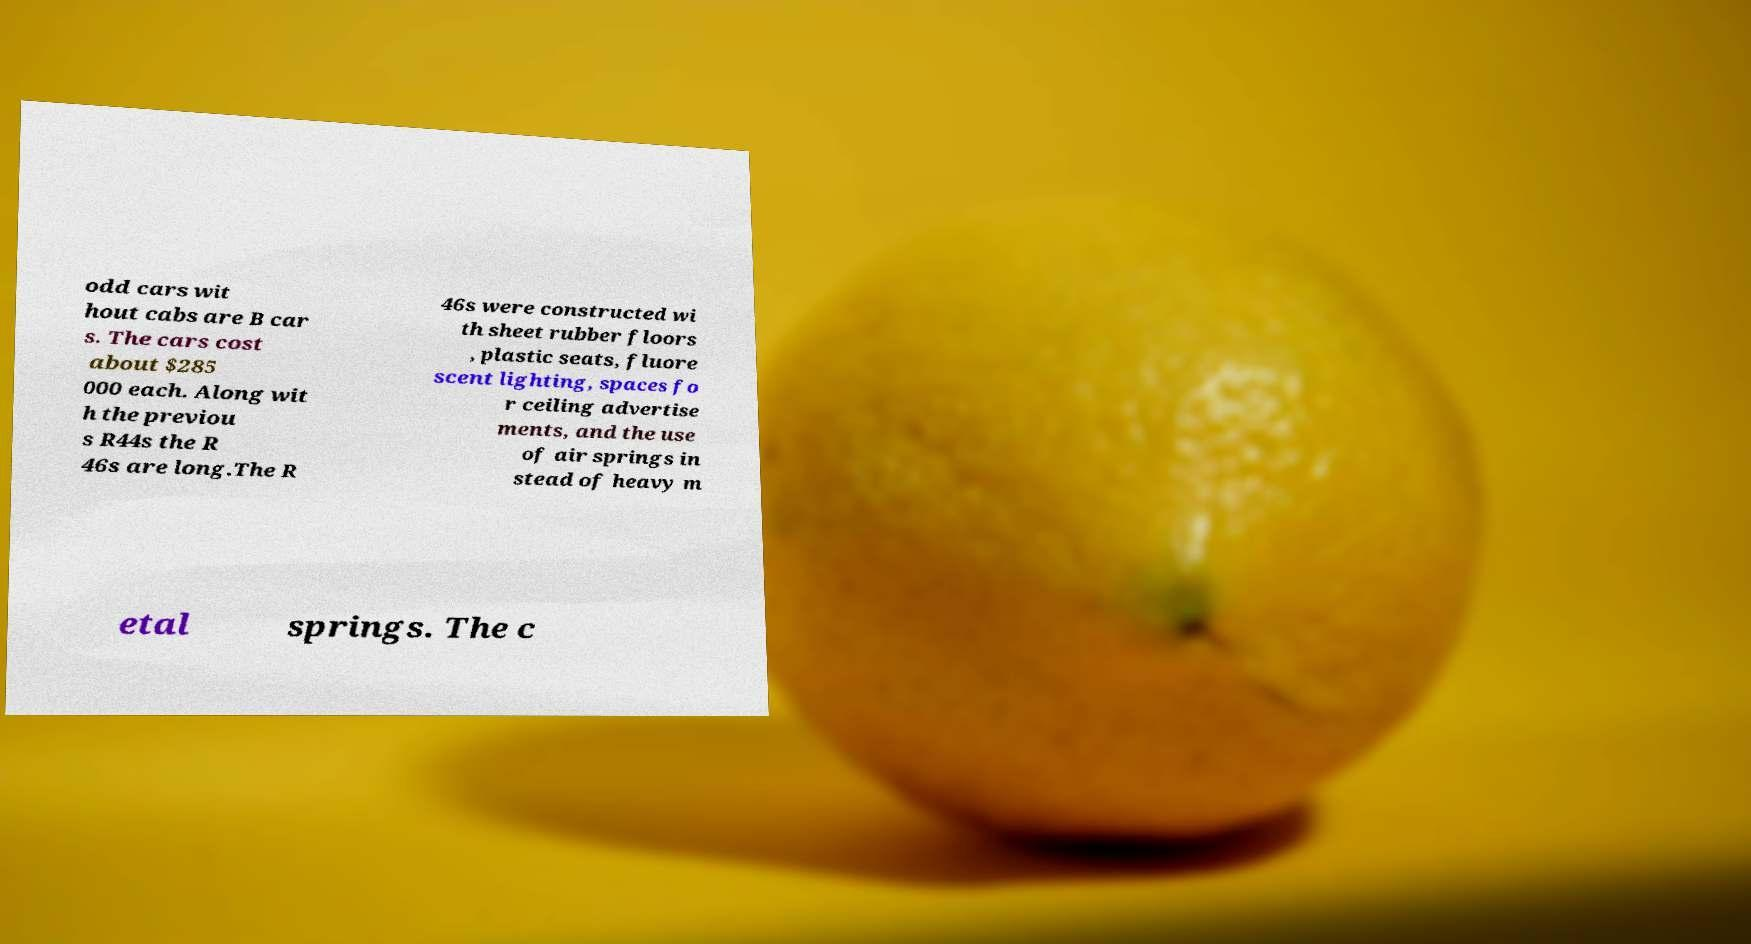Can you accurately transcribe the text from the provided image for me? odd cars wit hout cabs are B car s. The cars cost about $285 000 each. Along wit h the previou s R44s the R 46s are long.The R 46s were constructed wi th sheet rubber floors , plastic seats, fluore scent lighting, spaces fo r ceiling advertise ments, and the use of air springs in stead of heavy m etal springs. The c 